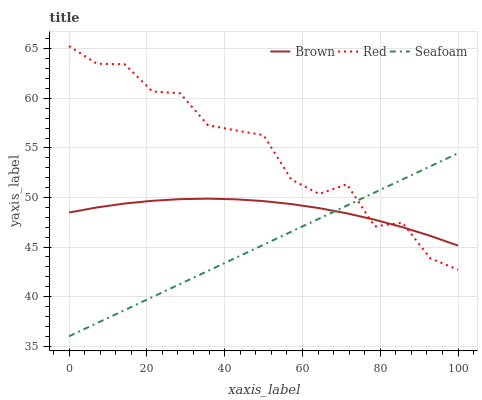Does Seafoam have the minimum area under the curve?
Answer yes or no. Yes. Does Red have the maximum area under the curve?
Answer yes or no. Yes. Does Red have the minimum area under the curve?
Answer yes or no. No. Does Seafoam have the maximum area under the curve?
Answer yes or no. No. Is Seafoam the smoothest?
Answer yes or no. Yes. Is Red the roughest?
Answer yes or no. Yes. Is Red the smoothest?
Answer yes or no. No. Is Seafoam the roughest?
Answer yes or no. No. Does Seafoam have the lowest value?
Answer yes or no. Yes. Does Red have the lowest value?
Answer yes or no. No. Does Red have the highest value?
Answer yes or no. Yes. Does Seafoam have the highest value?
Answer yes or no. No. Does Seafoam intersect Red?
Answer yes or no. Yes. Is Seafoam less than Red?
Answer yes or no. No. Is Seafoam greater than Red?
Answer yes or no. No. 